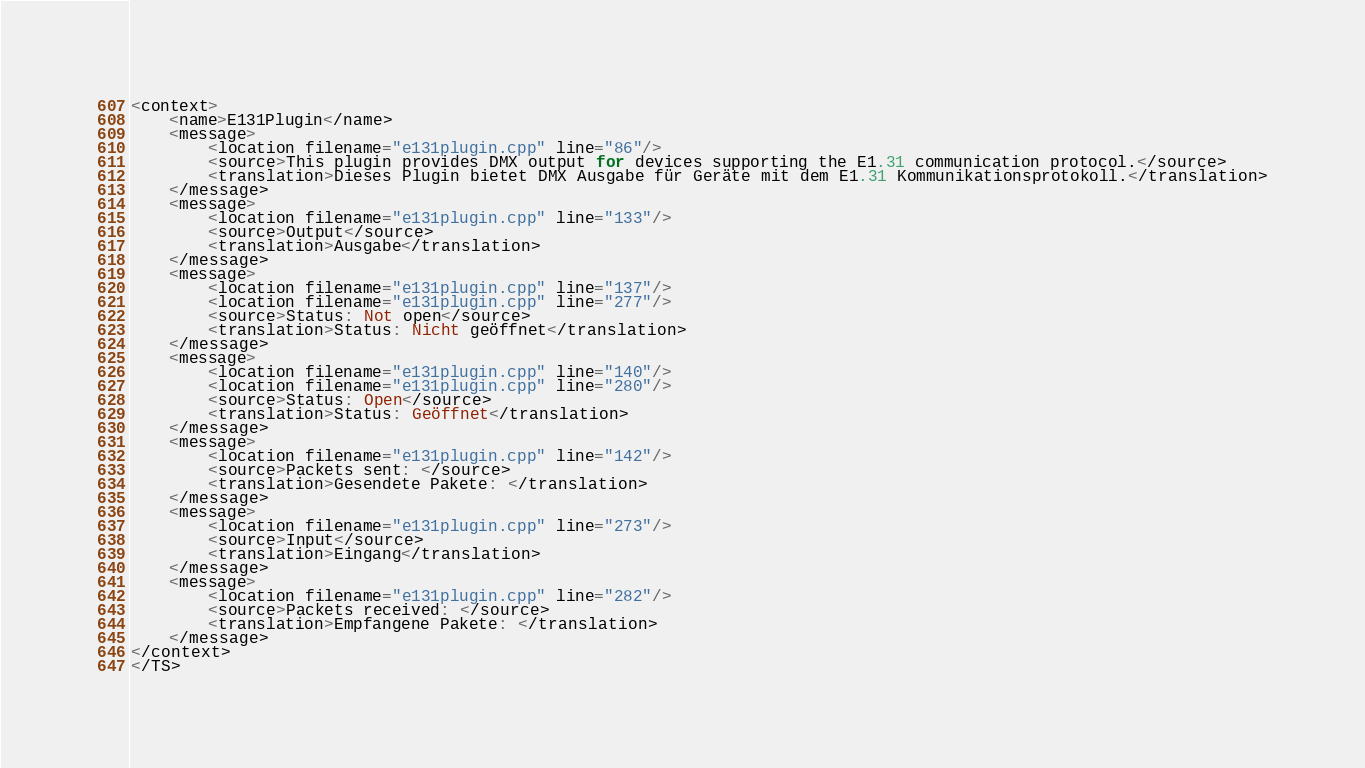Convert code to text. <code><loc_0><loc_0><loc_500><loc_500><_TypeScript_><context>
    <name>E131Plugin</name>
    <message>
        <location filename="e131plugin.cpp" line="86"/>
        <source>This plugin provides DMX output for devices supporting the E1.31 communication protocol.</source>
        <translation>Dieses Plugin bietet DMX Ausgabe für Geräte mit dem E1.31 Kommunikationsprotokoll.</translation>
    </message>
    <message>
        <location filename="e131plugin.cpp" line="133"/>
        <source>Output</source>
        <translation>Ausgabe</translation>
    </message>
    <message>
        <location filename="e131plugin.cpp" line="137"/>
        <location filename="e131plugin.cpp" line="277"/>
        <source>Status: Not open</source>
        <translation>Status: Nicht geöffnet</translation>
    </message>
    <message>
        <location filename="e131plugin.cpp" line="140"/>
        <location filename="e131plugin.cpp" line="280"/>
        <source>Status: Open</source>
        <translation>Status: Geöffnet</translation>
    </message>
    <message>
        <location filename="e131plugin.cpp" line="142"/>
        <source>Packets sent: </source>
        <translation>Gesendete Pakete: </translation>
    </message>
    <message>
        <location filename="e131plugin.cpp" line="273"/>
        <source>Input</source>
        <translation>Eingang</translation>
    </message>
    <message>
        <location filename="e131plugin.cpp" line="282"/>
        <source>Packets received: </source>
        <translation>Empfangene Pakete: </translation>
    </message>
</context>
</TS>
</code> 